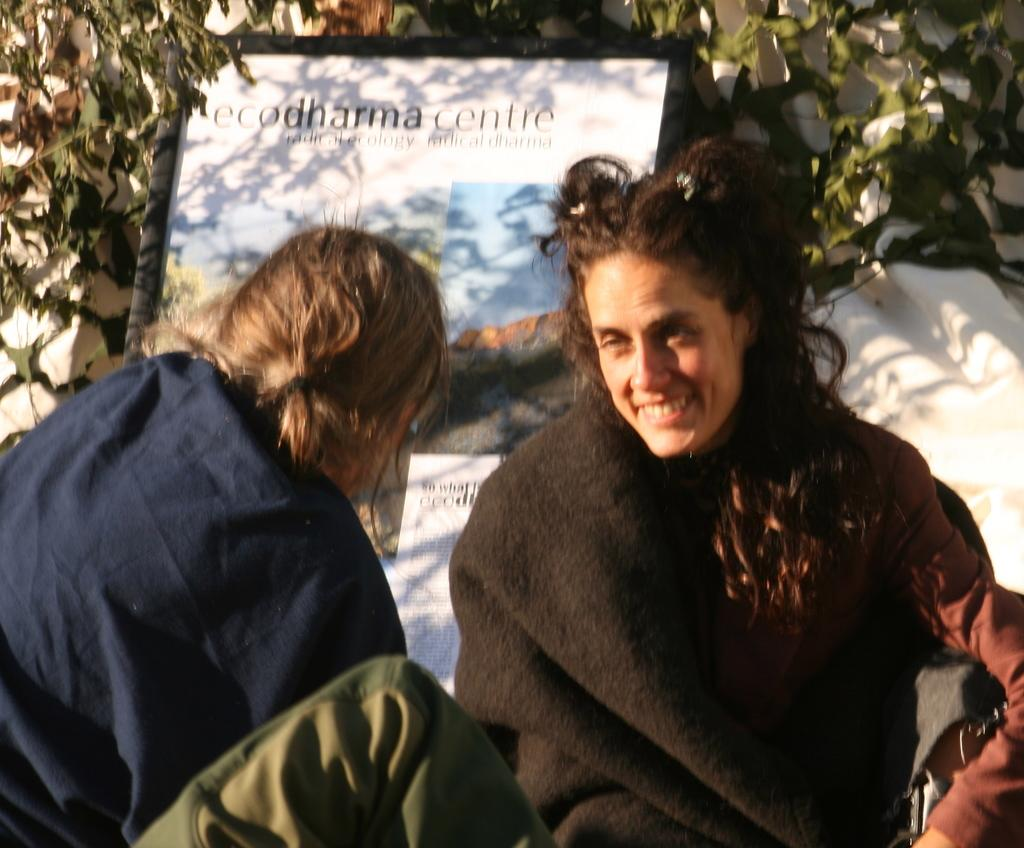Who or what can be seen in the image? There are people in the image. What is the board with text and images used for? The board with text and images is likely used for communication or displaying information. What type of natural elements are present in the background of the image? The background of the image includes leaves. What is the color of the object in the image? The object in the image is white. What type of cracker is being used in the process depicted in the image? There is no cracker or process visible in the image; it features people and a board with text and images. How many rods can be seen in the image? There are no rods present in the image. 